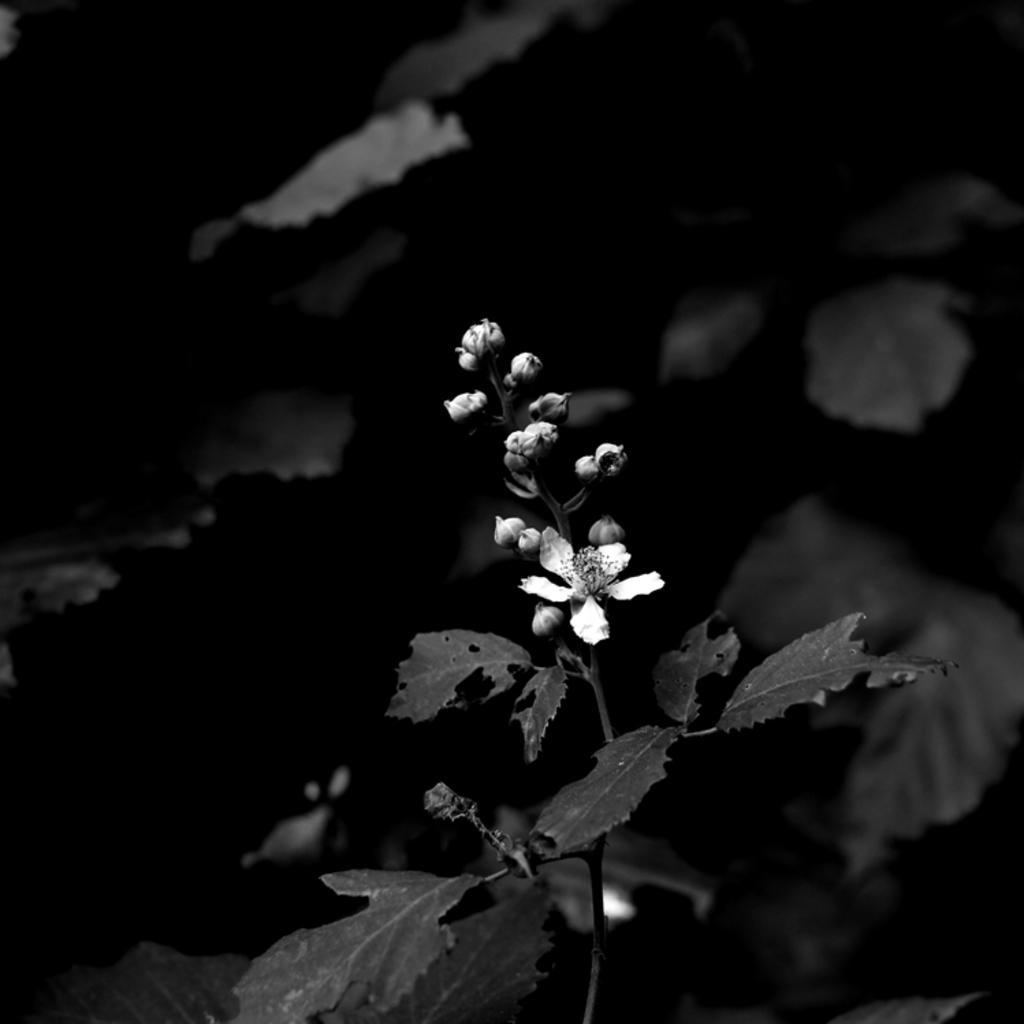Describe this image in one or two sentences. This is a dark image, we can see a flower and we can see some leaves. 